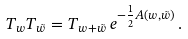<formula> <loc_0><loc_0><loc_500><loc_500>T _ { w } T _ { \tilde { w } } = T _ { w + \tilde { w } } \, e ^ { - \frac { 1 } { 2 } { A ( w , \tilde { w } ) } } \, .</formula> 